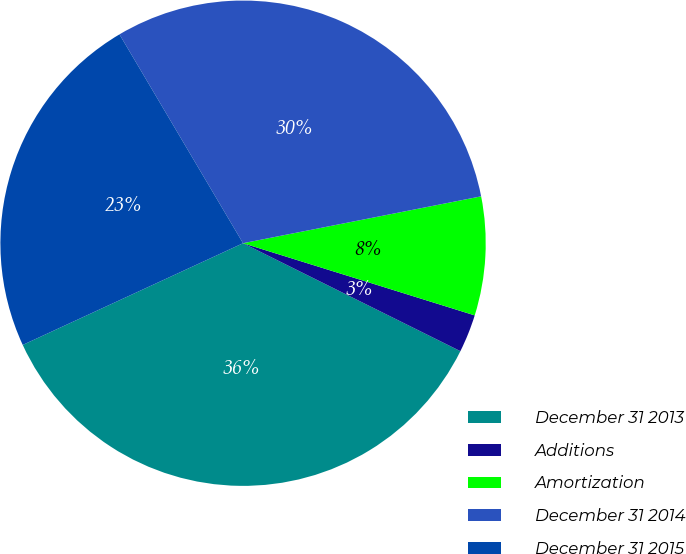Convert chart. <chart><loc_0><loc_0><loc_500><loc_500><pie_chart><fcel>December 31 2013<fcel>Additions<fcel>Amortization<fcel>December 31 2014<fcel>December 31 2015<nl><fcel>35.78%<fcel>2.53%<fcel>7.9%<fcel>30.41%<fcel>23.38%<nl></chart> 